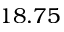<formula> <loc_0><loc_0><loc_500><loc_500>1 8 . 7 5</formula> 